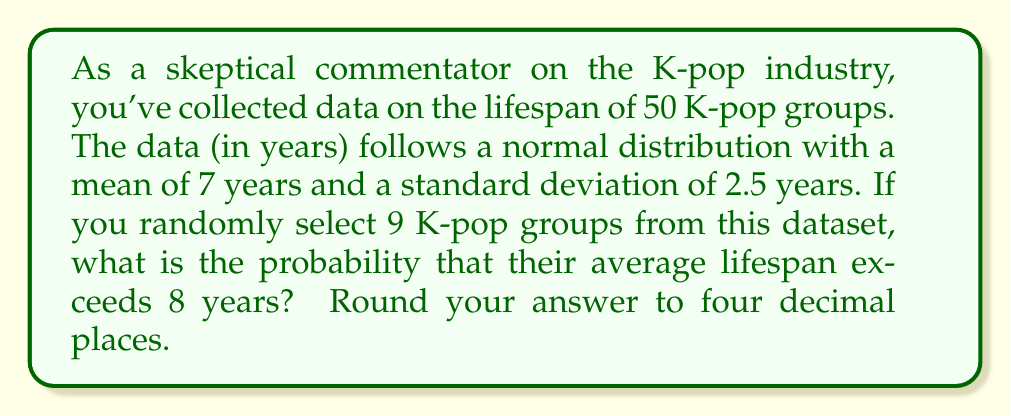Show me your answer to this math problem. Let's approach this step-by-step:

1) We're dealing with the sampling distribution of the mean. The Central Limit Theorem states that for a sufficiently large sample size (generally n ≥ 30), the sampling distribution of the mean is approximately normal, regardless of the underlying distribution.

2) Given:
   - Population mean (μ) = 7 years
   - Population standard deviation (σ) = 2.5 years
   - Sample size (n) = 9

3) The sampling distribution of the mean has:
   - Mean = μ = 7 years
   - Standard error (SE) = $\frac{\sigma}{\sqrt{n}} = \frac{2.5}{\sqrt{9}} = \frac{2.5}{3} \approx 0.8333$

4) We want to find P(X̄ > 8), where X̄ is the sample mean.

5) Standardize the score:
   $z = \frac{X - \mu}{SE} = \frac{8 - 7}{0.8333} = 1.2$

6) Now, we need to find P(Z > 1.2) where Z is a standard normal variable.

7) Using a standard normal table or calculator, we find:
   P(Z > 1.2) = 1 - P(Z < 1.2) = 1 - 0.8849 = 0.1151

8) Rounding to four decimal places: 0.1151

This result suggests that there's approximately an 11.51% chance that the average lifespan of 9 randomly selected K-pop groups from this dataset would exceed 8 years, which aligns with the skeptical view of the industry's volatility.
Answer: 0.1151 